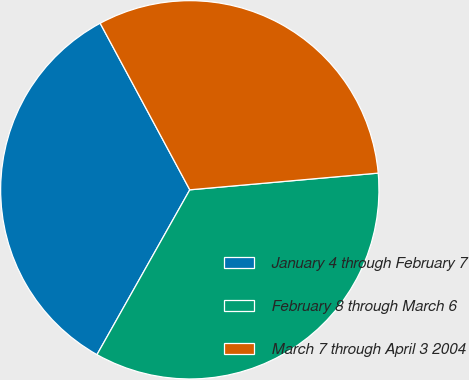Convert chart. <chart><loc_0><loc_0><loc_500><loc_500><pie_chart><fcel>January 4 through February 7<fcel>February 8 through March 6<fcel>March 7 through April 3 2004<nl><fcel>33.98%<fcel>34.57%<fcel>31.45%<nl></chart> 